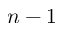<formula> <loc_0><loc_0><loc_500><loc_500>n - 1</formula> 